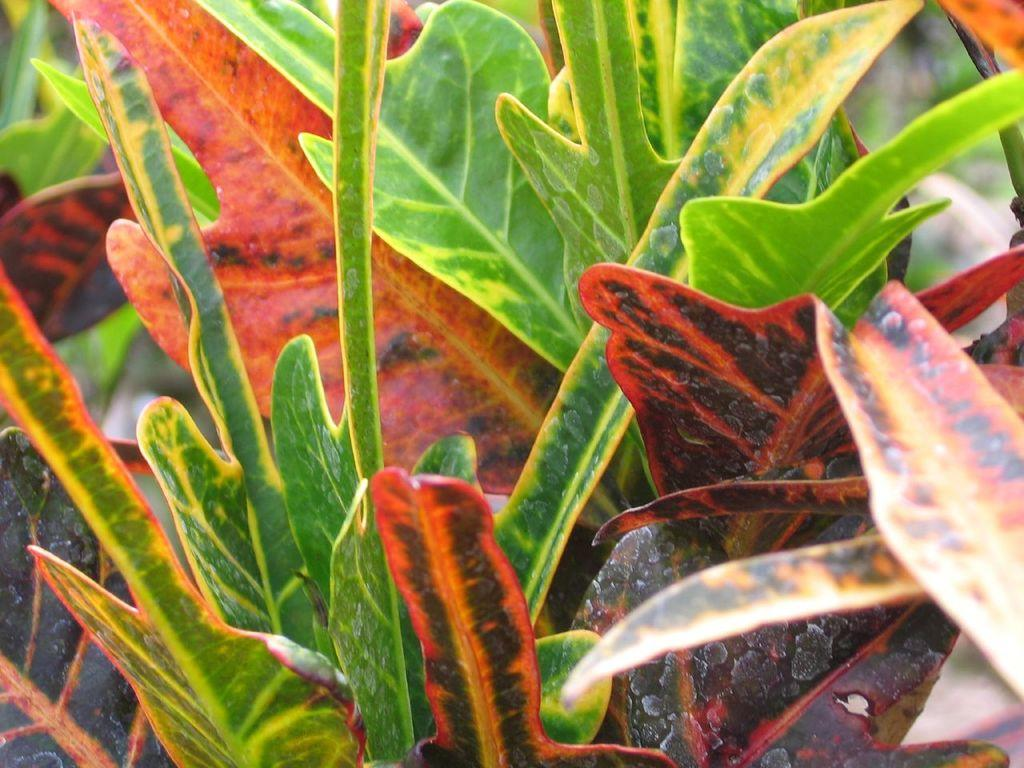What is the main subject of the image? The main subject of the image is leaves. Can you describe the leaves in the image? The leaves are green and red in color. What type of stamp can be seen on the roof in the image? There is no stamp or roof present in the image; it only features leaves. What season is depicted in the image, considering the presence of spring flowers? There is no mention of spring flowers or any seasonal indicators in the image; it only features green and red leaves. 